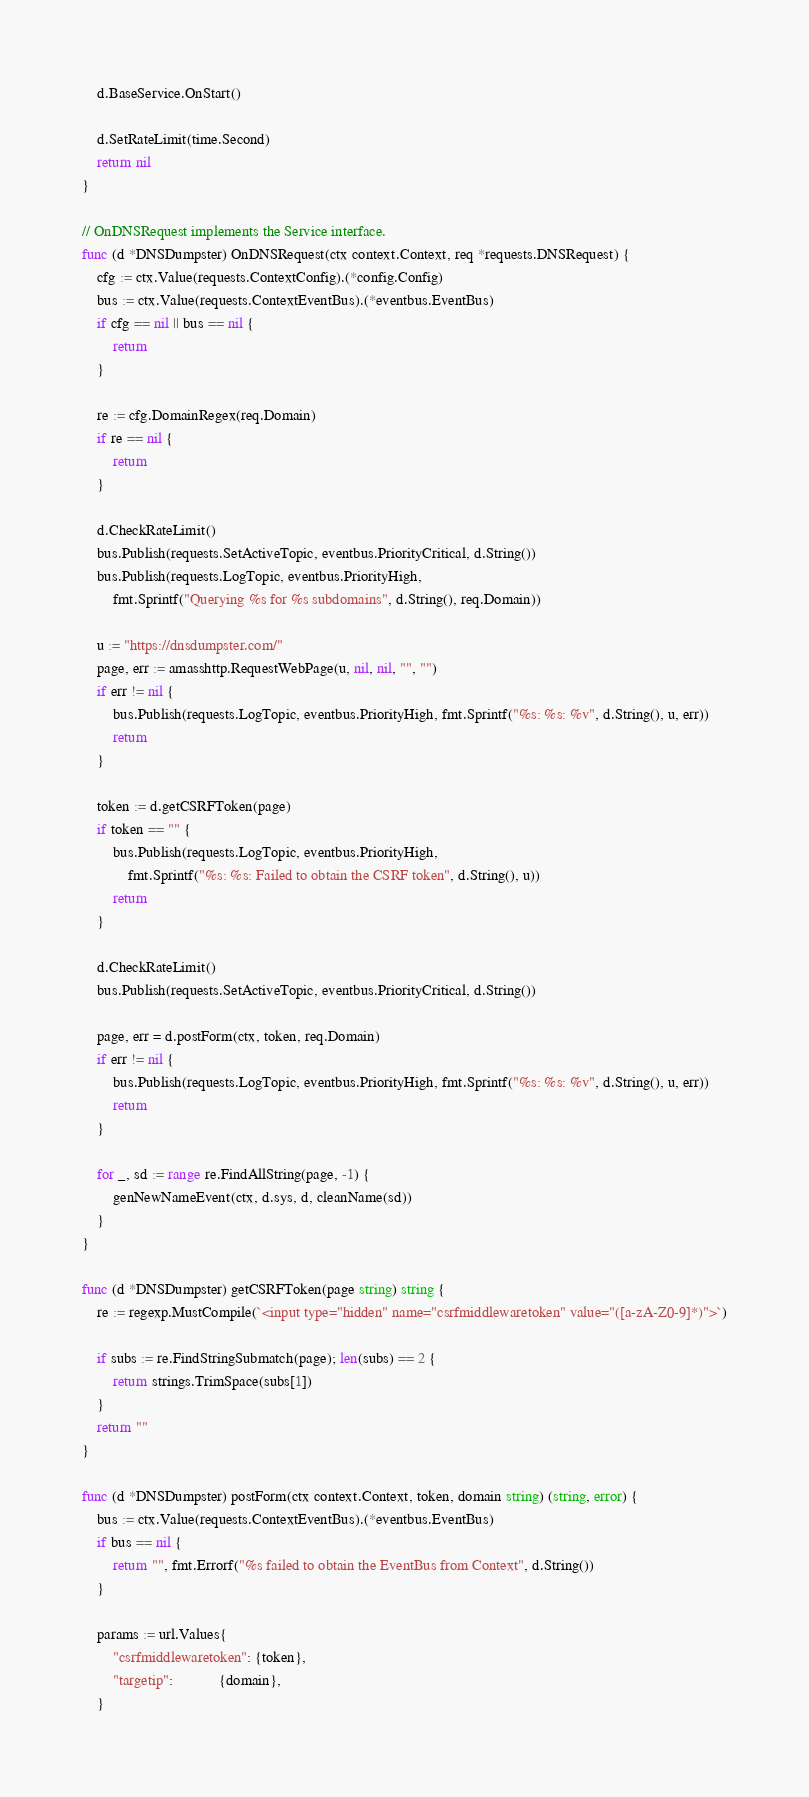Convert code to text. <code><loc_0><loc_0><loc_500><loc_500><_Go_>	d.BaseService.OnStart()

	d.SetRateLimit(time.Second)
	return nil
}

// OnDNSRequest implements the Service interface.
func (d *DNSDumpster) OnDNSRequest(ctx context.Context, req *requests.DNSRequest) {
	cfg := ctx.Value(requests.ContextConfig).(*config.Config)
	bus := ctx.Value(requests.ContextEventBus).(*eventbus.EventBus)
	if cfg == nil || bus == nil {
		return
	}

	re := cfg.DomainRegex(req.Domain)
	if re == nil {
		return
	}

	d.CheckRateLimit()
	bus.Publish(requests.SetActiveTopic, eventbus.PriorityCritical, d.String())
	bus.Publish(requests.LogTopic, eventbus.PriorityHigh,
		fmt.Sprintf("Querying %s for %s subdomains", d.String(), req.Domain))

	u := "https://dnsdumpster.com/"
	page, err := amasshttp.RequestWebPage(u, nil, nil, "", "")
	if err != nil {
		bus.Publish(requests.LogTopic, eventbus.PriorityHigh, fmt.Sprintf("%s: %s: %v", d.String(), u, err))
		return
	}

	token := d.getCSRFToken(page)
	if token == "" {
		bus.Publish(requests.LogTopic, eventbus.PriorityHigh,
			fmt.Sprintf("%s: %s: Failed to obtain the CSRF token", d.String(), u))
		return
	}

	d.CheckRateLimit()
	bus.Publish(requests.SetActiveTopic, eventbus.PriorityCritical, d.String())

	page, err = d.postForm(ctx, token, req.Domain)
	if err != nil {
		bus.Publish(requests.LogTopic, eventbus.PriorityHigh, fmt.Sprintf("%s: %s: %v", d.String(), u, err))
		return
	}

	for _, sd := range re.FindAllString(page, -1) {
		genNewNameEvent(ctx, d.sys, d, cleanName(sd))
	}
}

func (d *DNSDumpster) getCSRFToken(page string) string {
	re := regexp.MustCompile(`<input type="hidden" name="csrfmiddlewaretoken" value="([a-zA-Z0-9]*)">`)

	if subs := re.FindStringSubmatch(page); len(subs) == 2 {
		return strings.TrimSpace(subs[1])
	}
	return ""
}

func (d *DNSDumpster) postForm(ctx context.Context, token, domain string) (string, error) {
	bus := ctx.Value(requests.ContextEventBus).(*eventbus.EventBus)
	if bus == nil {
		return "", fmt.Errorf("%s failed to obtain the EventBus from Context", d.String())
	}

	params := url.Values{
		"csrfmiddlewaretoken": {token},
		"targetip":            {domain},
	}
</code> 